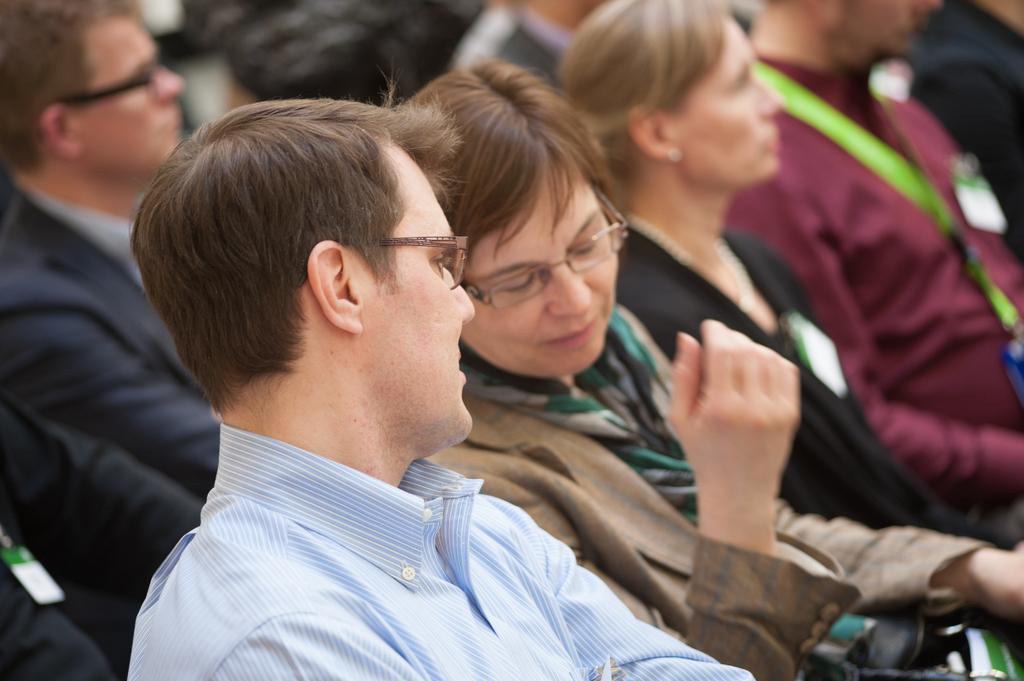Could you give a brief overview of what you see in this image? In the foreground of this picture, there is a man and a woman talking to each other. In the background, there are persons sitting. 